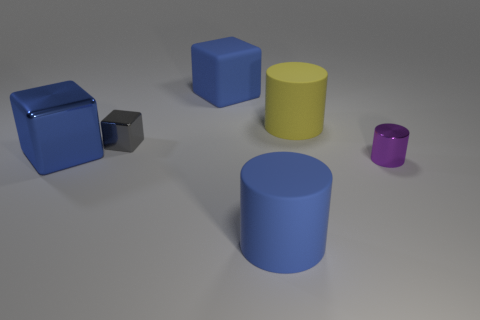How many other things are there of the same material as the large yellow object?
Provide a succinct answer. 2. There is a rubber block; are there any large yellow rubber cylinders in front of it?
Your response must be concise. Yes. There is a blue rubber block; does it have the same size as the cylinder that is in front of the small purple cylinder?
Give a very brief answer. Yes. What is the color of the rubber cylinder behind the blue thing in front of the purple metal cylinder?
Your response must be concise. Yellow. Does the blue matte cylinder have the same size as the purple cylinder?
Your answer should be very brief. No. What is the color of the rubber object that is behind the tiny purple cylinder and left of the yellow rubber cylinder?
Keep it short and to the point. Blue. How big is the yellow cylinder?
Your answer should be very brief. Large. Do the cylinder behind the tiny cylinder and the large metallic object have the same color?
Your answer should be compact. No. Is the number of yellow rubber objects behind the yellow thing greater than the number of large cylinders that are behind the small purple metallic thing?
Provide a succinct answer. No. Are there more purple things than rubber objects?
Your answer should be very brief. No. 